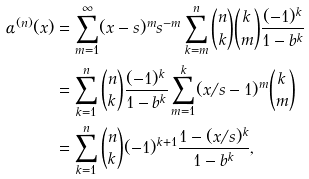<formula> <loc_0><loc_0><loc_500><loc_500>\alpha ^ { ( n ) } ( x ) & = \sum _ { m = 1 } ^ { \infty } ( x - s ) ^ { m } s ^ { - m } \sum _ { k = m } ^ { n } \binom { n } { k } \binom { k } { m } \frac { ( - 1 ) ^ { k } } { 1 - b ^ { k } } \\ & = \sum _ { k = 1 } ^ { n } \binom { n } { k } \frac { ( - 1 ) ^ { k } } { 1 - b ^ { k } } \sum _ { m = 1 } ^ { k } ( x / s - 1 ) ^ { m } \binom { k } { m } \\ & = \sum _ { k = 1 } ^ { n } \binom { n } { k } ( - 1 ) ^ { k + 1 } \frac { 1 - ( x / s ) ^ { k } } { 1 - b ^ { k } } ,</formula> 